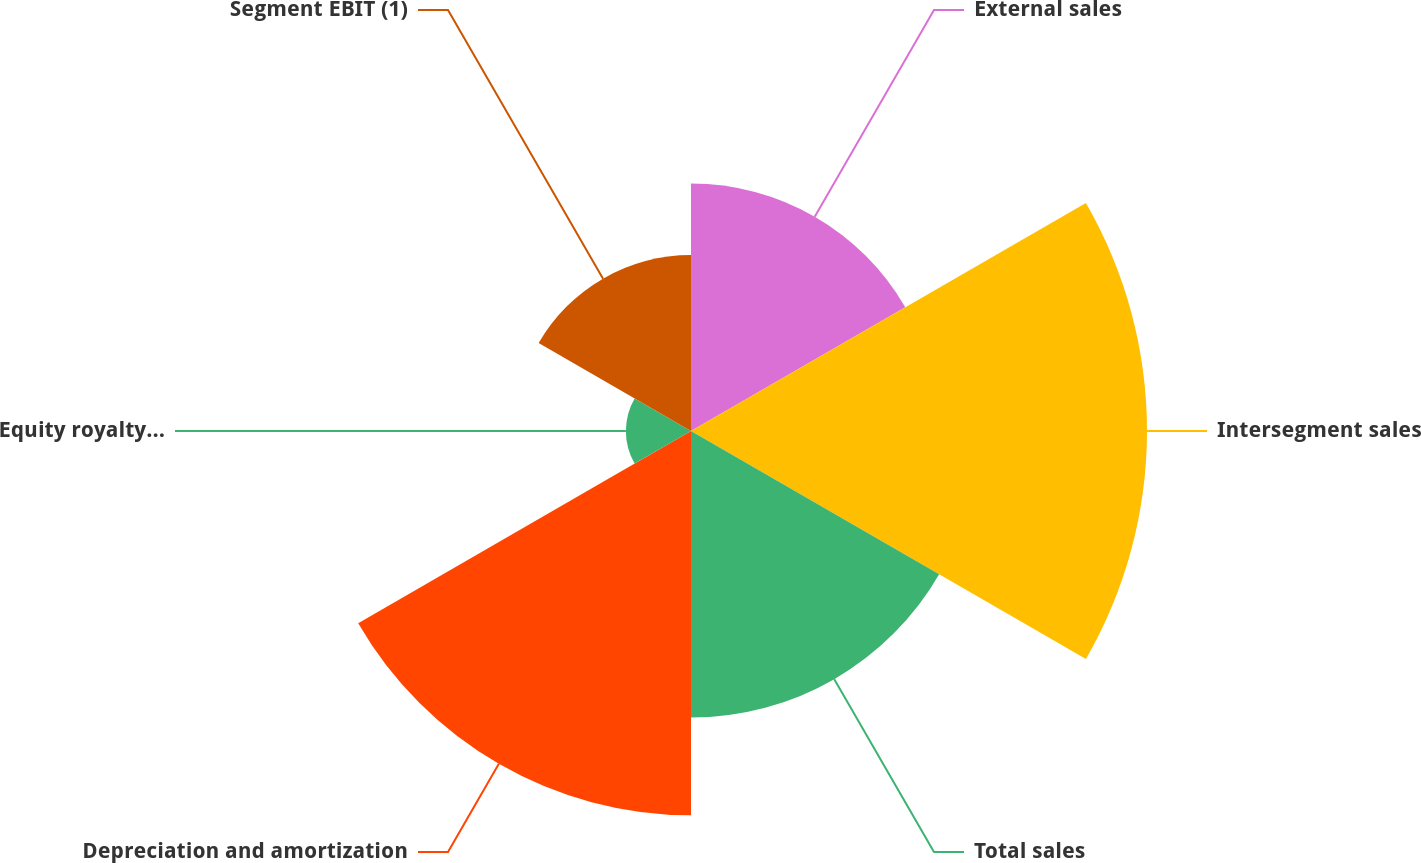Convert chart to OTSL. <chart><loc_0><loc_0><loc_500><loc_500><pie_chart><fcel>External sales<fcel>Intersegment sales<fcel>Total sales<fcel>Depreciation and amortization<fcel>Equity royalty and interest<fcel>Segment EBIT (1)<nl><fcel>15.32%<fcel>28.23%<fcel>17.74%<fcel>23.79%<fcel>4.03%<fcel>10.89%<nl></chart> 